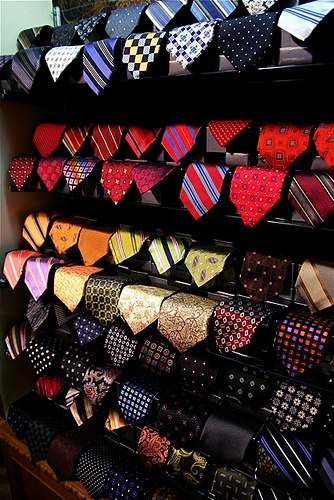Describe the objects in this image and their specific colors. I can see tie in white, brown, black, and maroon tones, tie in white, black, maroon, brown, and red tones, tie in white, black, navy, gray, and lightgray tones, tie in white, gray, and tan tones, and tie in white, red, and brown tones in this image. 